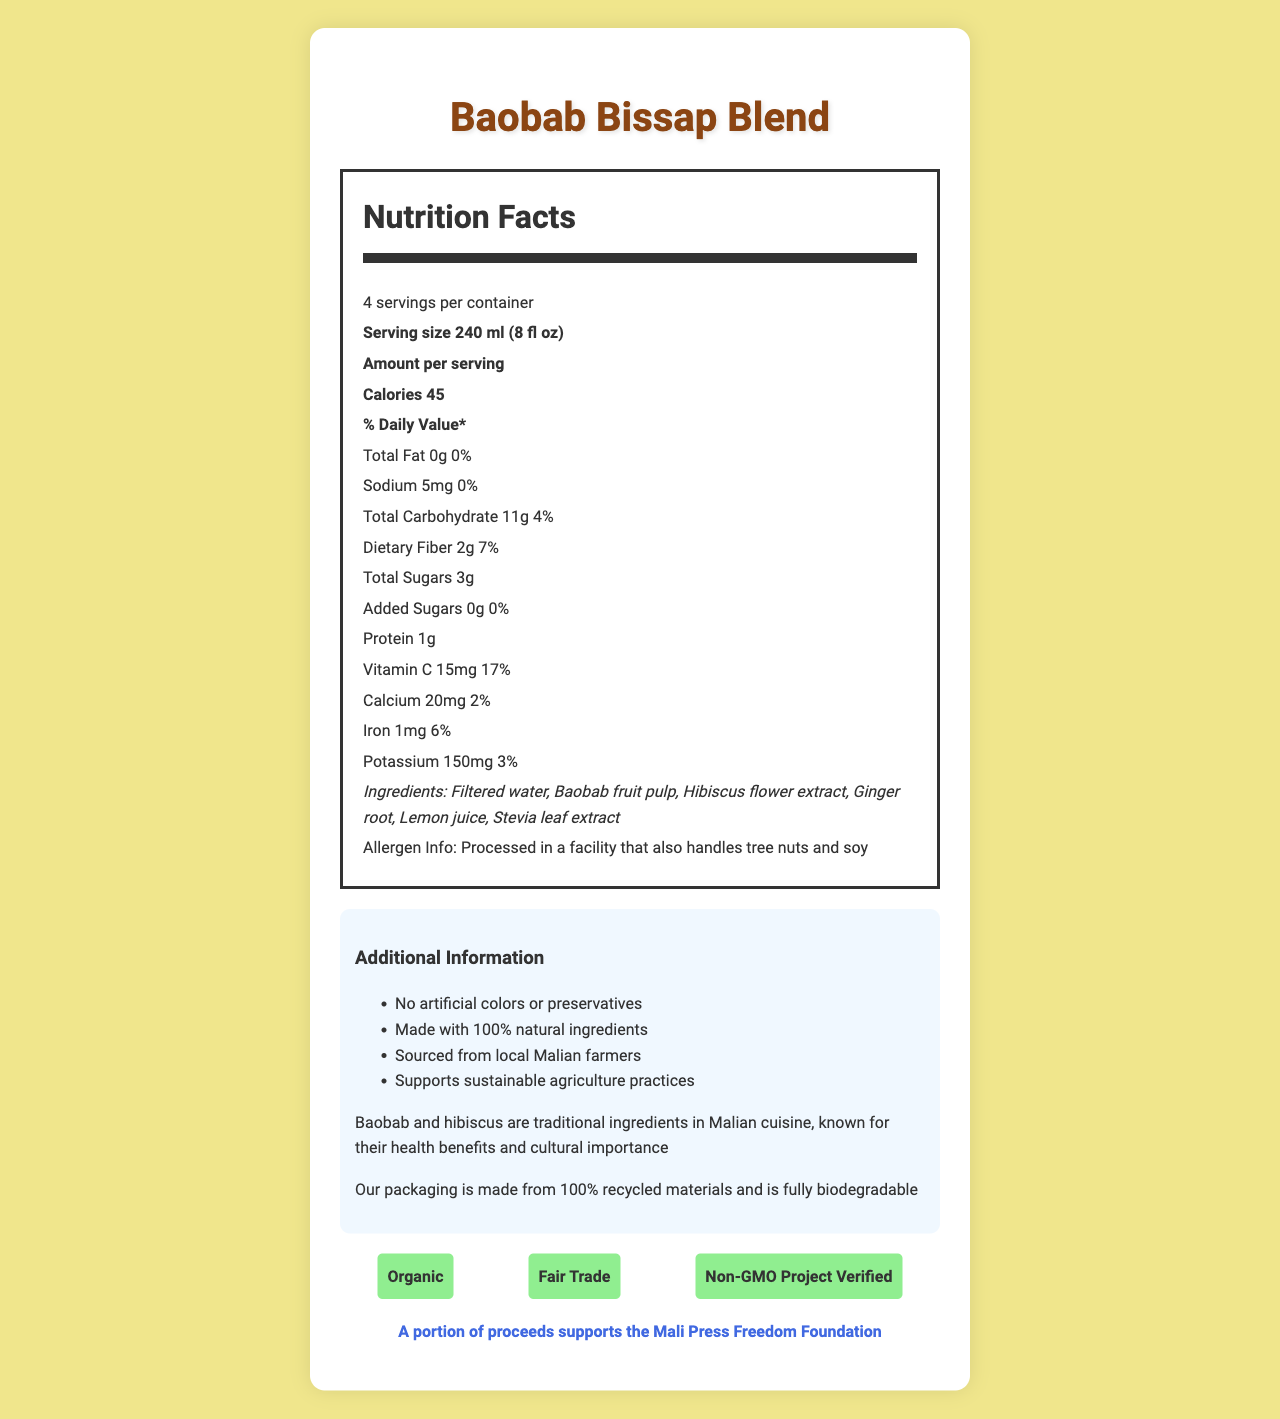what is the product name? The product name is prominently displayed at the top of the document.
Answer: Baobab Bissap Blend What is the serving size? The serving size is listed under the nutrition facts section.
Answer: 240 ml (8 fl oz) How many calories are in one serving? The calories per serving are indicated in the nutrition facts.
Answer: 45 calories What is the total amount of sugars in one serving? The total amount of sugars is specified in the nutrition facts.
Answer: 3g Are there any added sugars in the beverage? The document specifies that there are 0g of added sugars.
Answer: No Which vitamin has the highest percent daily value? A. Vitamin C B. Calcium C. Iron D. Potassium Vitamin C has a 17% daily value, which is the highest among the listed vitamins and minerals.
Answer: A. Vitamin C What is the manufacturer's name and location? A. Sahel Enterprises, Sikasso, Mali B. Sahel Beverages Co-op, Bamako, Mali C. Mali Beverage Corp, Bamako, Mali The manufacturer's name and location are listed at the bottom of the document.
Answer: B. Sahel Beverages Co-op, Bamako, Mali Does the product contain any artificial colors or preservatives? The document states that the product has no artificial colors or preservatives.
Answer: No Is this product processed in a facility that handles any allergens? The allergen information reveals that it is processed in a facility that also handles tree nuts and soy.
Answer: Yes Summarize the main features and attributes of the Baobab Bissap Blend. The document outlines the nutritional facts, ingredients, certifications, and additional information about sustainability and cultural significance, along with the press freedom message.
Answer: Baobab Bissap Blend is a local beverage made with natural ingredients like baobab fruit pulp and hibiscus flower extract. It has low sugar content (3g per serving) and no added sugars. Each serving contains 45 calories, 2g of dietary fiber, and 15mg of Vitamin C. The product supports sustainable agriculture practices and is certified organic, fair trade, and non-GMO. It is manufactured by Sahel Beverages Co-op in Bamako, Mali, and a portion of proceeds supports the Mali Press Freedom Foundation. How many servings are in one container of Baobab Bissap Blend? The nutrition facts indicate there are 4 servings per container.
Answer: 4 What is the total fat content per serving? The nutrition facts display that there is 0g of total fat per serving.
Answer: 0g Does the document specify the dietary fiber content? The nutrition facts show that each serving contains 2g of dietary fiber.
Answer: Yes, 2g per serving What are the natural ingredients in this beverage? The ingredients list includes these natural components.
Answer: Filtered water, Baobab fruit pulp, Hibiscus flower extract, Ginger root, Lemon juice, Stevia leaf extract Does the beverage contain more vitamin C or iron? The beverage contains 17% of the daily value of Vitamin C compared to 6% of the daily value of iron.
Answer: Vitamin C Can the cultural significance of the ingredients be determined from the document? The document mentions that baobab and hibiscus are traditional ingredients in Malian cuisine, known for their health benefits and cultural importance.
Answer: Yes What is the primary function of the press freedom message in the document? The press freedom message is included to inform consumers that part of the proceeds helps to support the Mali Press Freedom Foundation.
Answer: To highlight that a portion of the proceeds supports the Mali Press Freedom Foundation Which ingredient is used as a natural sweetener in the beverage? The ingredients list indicates that Stevia leaf extract is used as a natural sweetener.
Answer: Stevia leaf extract What is the packaging material, according to the sustainability statement? The sustainability statement specifies that the packaging is made from 100% recycled materials and is fully biodegradable.
Answer: 100% recycled materials and is fully biodegradable Does the document provide information on where the ingredients are sourced from? The document states that the ingredients are sourced from local Malian farmers.
Answer: Yes, from local Malian farmers How much sodium is in one serving? The nutrition facts list the sodium content as 5mg per serving.
Answer: 5mg Who certifies the product as organic, fair trade, and non-GMO? The specific certifying bodies are not mentioned in the document.
Answer: Not enough information 